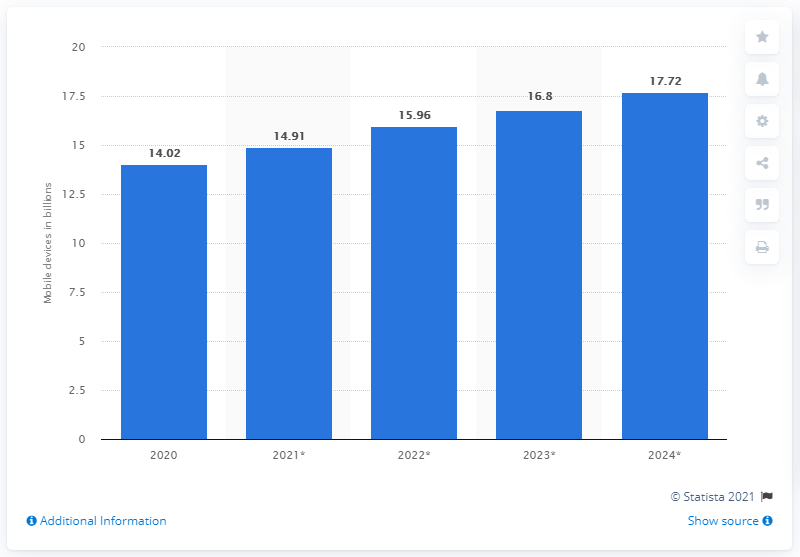List a handful of essential elements in this visual. It is predicted that by the year 2020, there will be 17.72 billion mobile devices in circulation. By 2024, it is projected that there will be 17.72 billion mobile devices operating worldwide. 